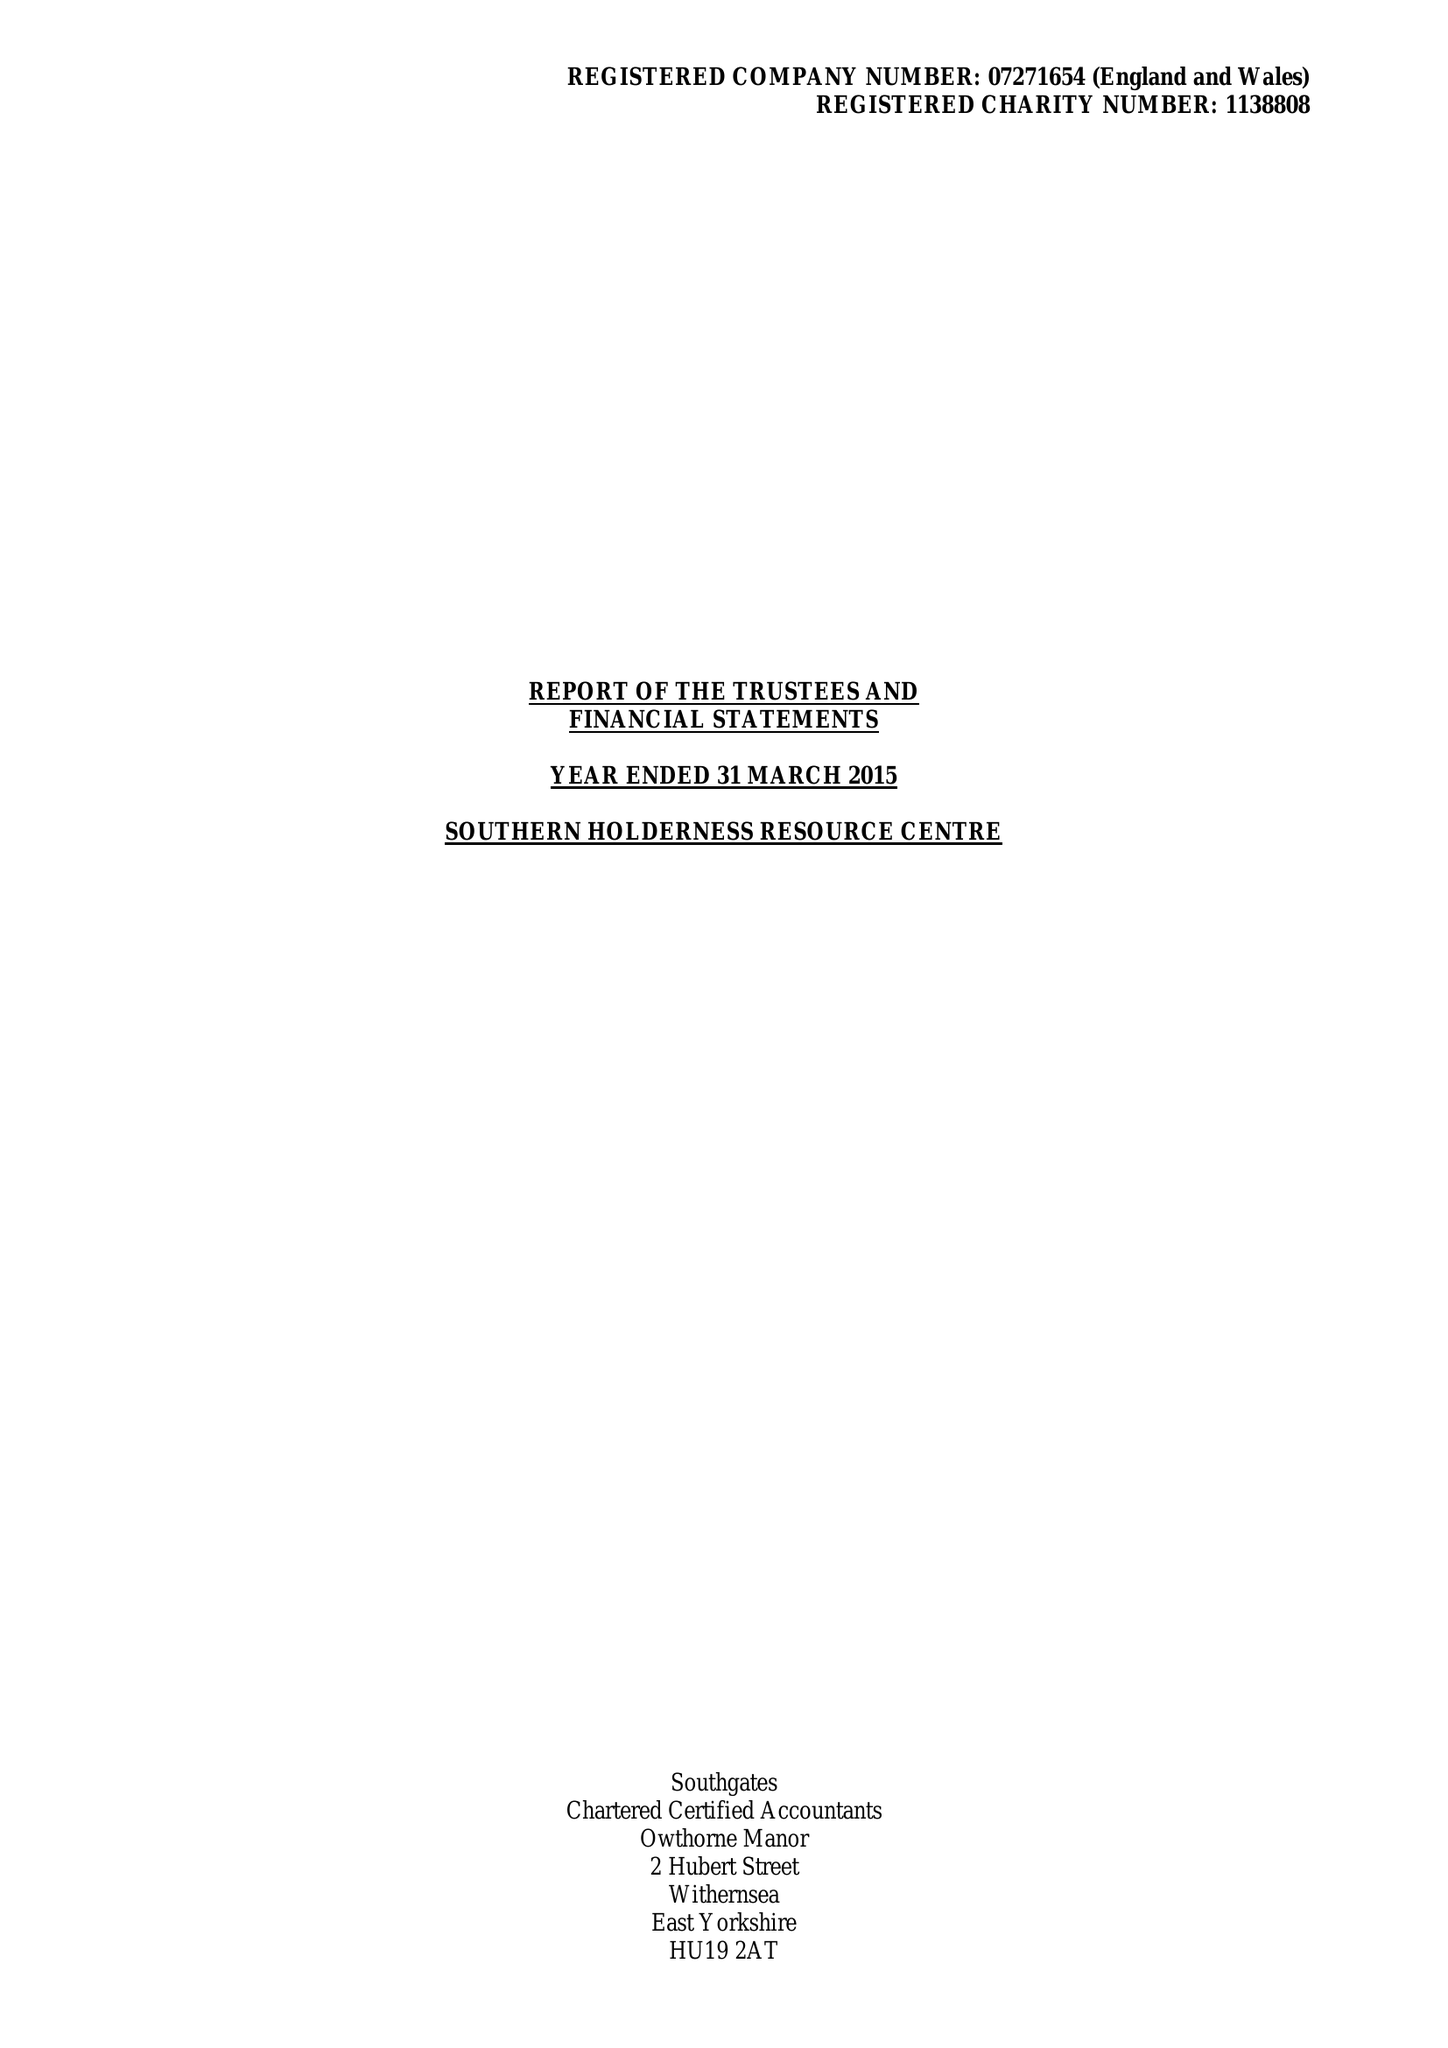What is the value for the address__street_line?
Answer the question using a single word or phrase. 29-31 SEASIDE ROAD 